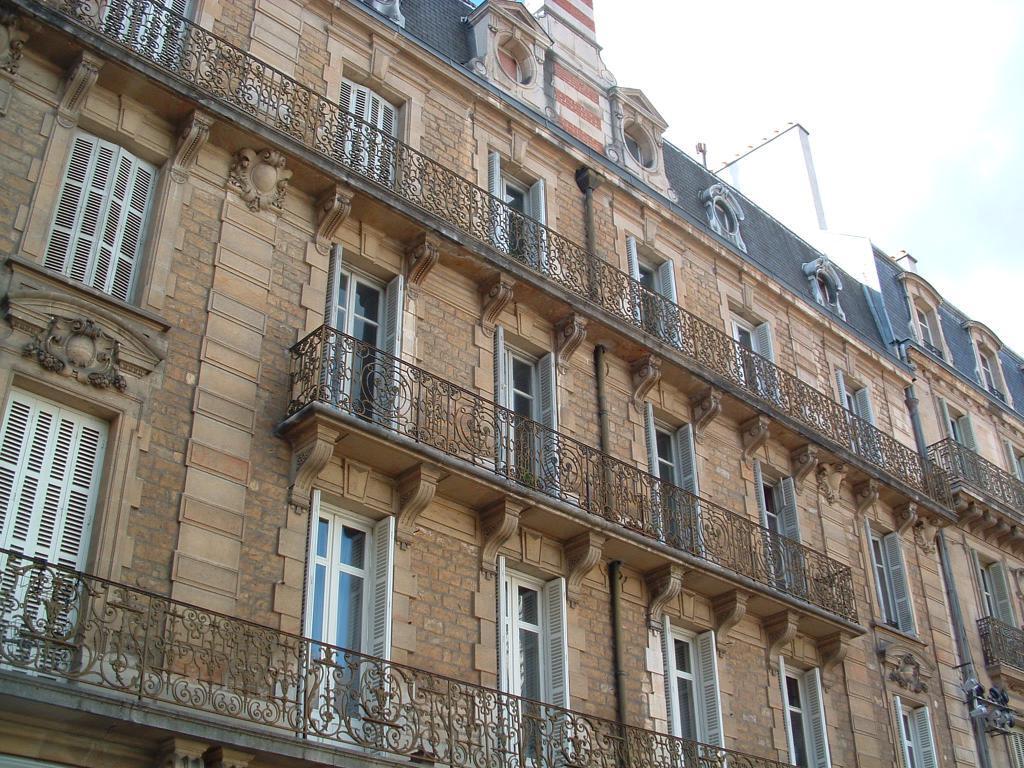In one or two sentences, can you explain what this image depicts? In the foreground I can see buildings, windows and a fence. In the right top I can see the sky. This image is taken may be in a day. 